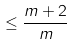Convert formula to latex. <formula><loc_0><loc_0><loc_500><loc_500>\leq \frac { m + 2 } { m } \\</formula> 